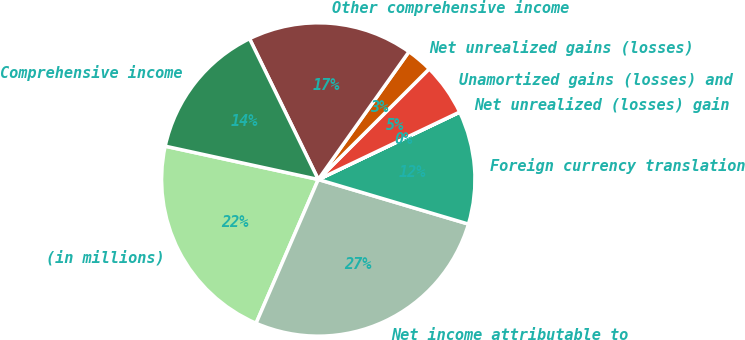Convert chart to OTSL. <chart><loc_0><loc_0><loc_500><loc_500><pie_chart><fcel>(in millions)<fcel>Net income attributable to<fcel>Foreign currency translation<fcel>Net unrealized (losses) gain<fcel>Unamortized gains (losses) and<fcel>Net unrealized gains (losses)<fcel>Other comprehensive income<fcel>Comprehensive income<nl><fcel>21.91%<fcel>26.9%<fcel>11.67%<fcel>0.01%<fcel>5.39%<fcel>2.7%<fcel>17.05%<fcel>14.36%<nl></chart> 